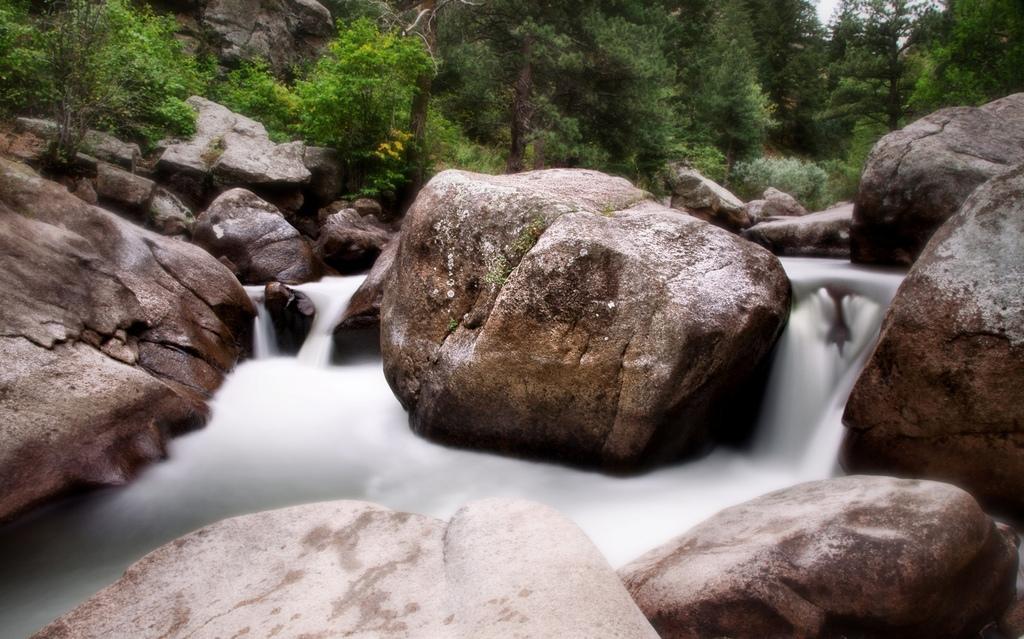Please provide a concise description of this image. in this image we can see there are rocks. In between the rocks there is a water flow. And at the back there are trees. 